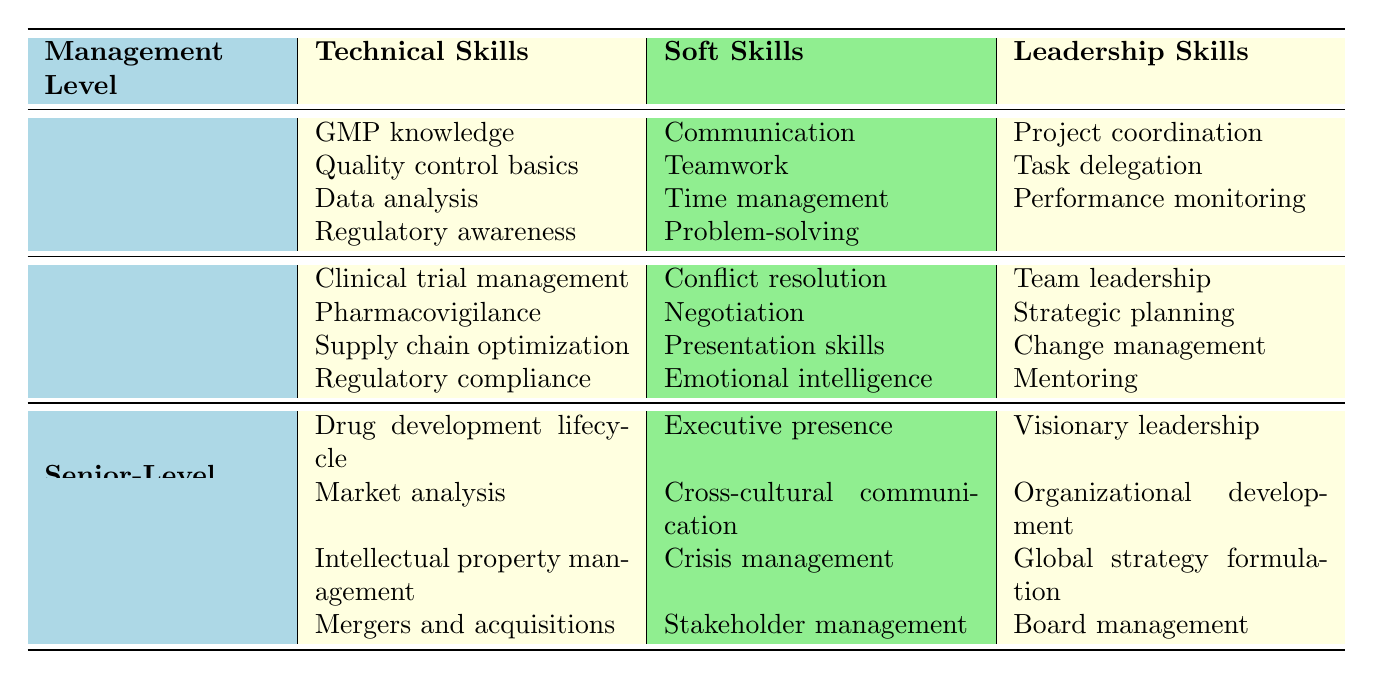What technical skill is required for Entry-Level Management? Entry-Level Management requires knowledge in GMP, quality control basics, data analysis, and regulatory awareness. The question asks for a specific category of skills, which can be found directly in the table under Entry-Level Management.
Answer: GMP knowledge How many soft skills are listed for Mid-Level Management? For Mid-Level Management, there are four soft skills mentioned: conflict resolution, negotiation, presentation skills, and emotional intelligence. By counting these listed items, we can determine the total.
Answer: 4 Is project coordination a leadership skill for Senior-Level Management? Checking the table for Senior-Level Management, project coordination is not listed as a leadership skill; instead, the skills listed are visionary leadership, organizational development, global strategy formulation, and board management. Therefore, the answer to the question is no.
Answer: No What is the difference in the number of soft skills between Entry-Level and Senior-Level Management? Entry-Level Management lists four soft skills, while Senior-Level Management also lists four soft skills. The difference is obtained by subtracting the number of soft skills: 4 (Entry) - 4 (Senior) = 0.
Answer: 0 Which management level has the skill "Crisis management"? Looking at the table, "Crisis management" is listed under Senior-Level Management. This requires scanning the leadership skills for each management level and identifying where the skill appears.
Answer: Senior-Level Management What are three leadership skills required for Mid-Level Management? The table shows that Mid-Level Management requires team leadership, strategic planning, change management, and mentoring. The question specifies to name three of them, which can be extracted directly from the corresponding row in the table.
Answer: Team leadership, strategic planning, change management Is there a technical skill listed for Entry-Level Management that relates to regulatory processes? Yes, regulatory awareness is a technical skill under Entry-Level Management. This is answered by reviewing the technical skills listed under that management level.
Answer: Yes Which skills are unique to Senior-Level Management compared to other management levels? The table lists four technical skills unique to Senior-Level Management: drug development lifecycle, market analysis, intellectual property management, and mergers and acquisitions. By comparing the lists from all three levels, we can identify the skills that are not shared with Entry-Level or Mid-Level Management.
Answer: Drug development lifecycle, market analysis, intellectual property management, mergers and acquisitions What is the total number of technical skills required across all management levels? Counting the technical skills listed: 4 (Entry-Level) + 4 (Mid-Level) + 4 (Senior-Level) gives a total of 12 technical skills. The total is simply the sum of the technical skills in the table.
Answer: 12 Which management level has skills that focus on "teamwork" and "visionary leadership"? "Teamwork" is a soft skill associated with Entry-Level Management, while "visionary leadership" is a leadership skill for Senior-Level Management. Hence, the question specifies two different management levels for each skill.
Answer: Entry-Level and Senior-Level Management 